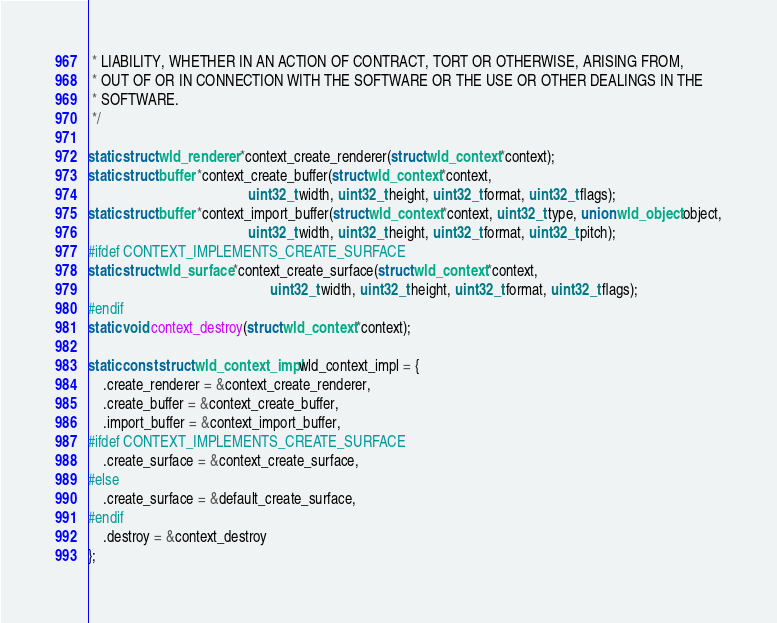Convert code to text. <code><loc_0><loc_0><loc_500><loc_500><_C_> * LIABILITY, WHETHER IN AN ACTION OF CONTRACT, TORT OR OTHERWISE, ARISING FROM,
 * OUT OF OR IN CONNECTION WITH THE SOFTWARE OR THE USE OR OTHER DEALINGS IN THE
 * SOFTWARE.
 */

static struct wld_renderer *context_create_renderer(struct wld_context *context);
static struct buffer *context_create_buffer(struct wld_context *context,
                                            uint32_t width, uint32_t height, uint32_t format, uint32_t flags);
static struct buffer *context_import_buffer(struct wld_context *context, uint32_t type, union wld_object object,
                                            uint32_t width, uint32_t height, uint32_t format, uint32_t pitch);
#ifdef CONTEXT_IMPLEMENTS_CREATE_SURFACE
static struct wld_surface *context_create_surface(struct wld_context *context,
                                                  uint32_t width, uint32_t height, uint32_t format, uint32_t flags);
#endif
static void context_destroy(struct wld_context *context);

static const struct wld_context_impl wld_context_impl = {
	.create_renderer = &context_create_renderer,
	.create_buffer = &context_create_buffer,
	.import_buffer = &context_import_buffer,
#ifdef CONTEXT_IMPLEMENTS_CREATE_SURFACE
	.create_surface = &context_create_surface,
#else
	.create_surface = &default_create_surface,
#endif
	.destroy = &context_destroy
};
</code> 